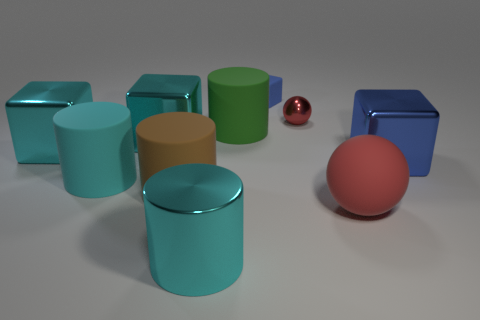Subtract 1 blocks. How many blocks are left? 3 Subtract all balls. How many objects are left? 8 Add 2 cyan matte things. How many cyan matte things exist? 3 Subtract 0 purple balls. How many objects are left? 10 Subtract all metal things. Subtract all brown cubes. How many objects are left? 5 Add 3 cyan cubes. How many cyan cubes are left? 5 